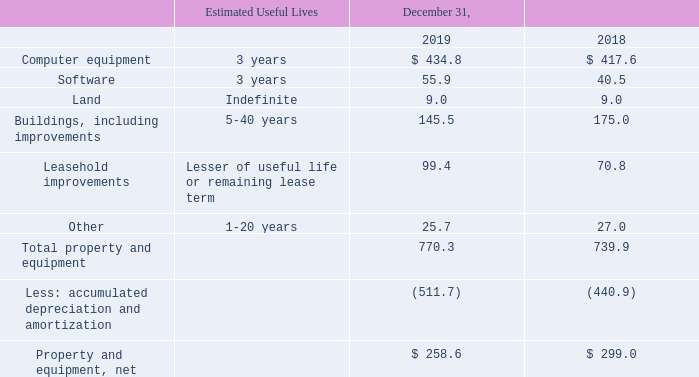Property and equipment consisted of the following:
Depreciation and amortization expense related to property and equipment was $86.5 million, $97.4 million and $88.8 million during 2019, 2018 and 2017, respectively.
Property and Equipment
Property and equipment is stated at cost. Depreciation is recorded over the shorter of the estimated useful life or the lease term of the applicable assets using the straight-line method beginning on the date an asset is placed in service. We regularly evaluate the estimated remaining useful lives of our property and equipment to determine whether events or changes in circumstances warrant a revision to the remaining period of depreciation. Maintenance and repairs are charged to expense as incurred.
What is the useful life of computer equipment? 3 years. What is the useful life of land? Indefinite. What is the useful life of buildings, including improvements? 5-40 years. What is the 2019 accumulated depreciation and amortization expense excluding the property and equipment depreciation and amortization expense?
Answer scale should be: million. -511.7+86.5
Answer: -425.2. What is the 2018 accumulated depreciation and amortization expense excluding the property and equipment depreciation and amortization expense?
Answer scale should be: million. -440.9+97.4
Answer: -343.5. Between 2018 and 2019 year end, which year had more total property and equipment? 770.3>739.9
Answer: 2019. 